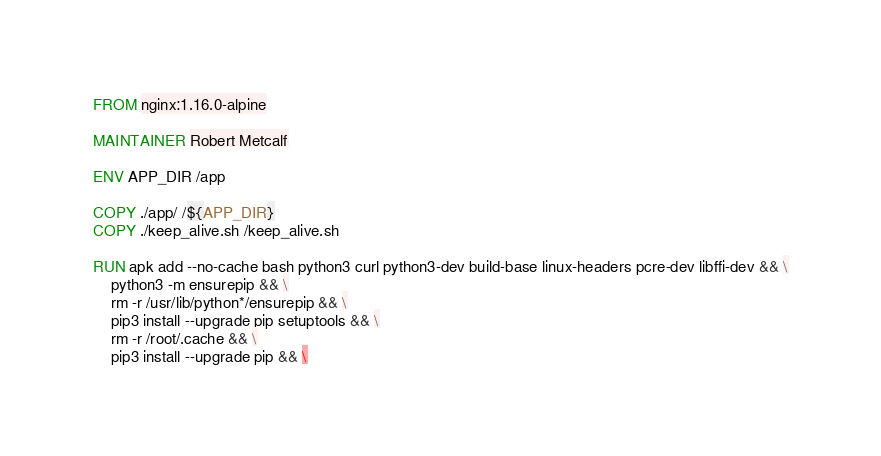Convert code to text. <code><loc_0><loc_0><loc_500><loc_500><_Dockerfile_>FROM nginx:1.16.0-alpine

MAINTAINER Robert Metcalf

ENV APP_DIR /app

COPY ./app/ /${APP_DIR}
COPY ./keep_alive.sh /keep_alive.sh

RUN apk add --no-cache bash python3 curl python3-dev build-base linux-headers pcre-dev libffi-dev && \
    python3 -m ensurepip && \
    rm -r /usr/lib/python*/ensurepip && \
    pip3 install --upgrade pip setuptools && \
    rm -r /root/.cache && \
    pip3 install --upgrade pip && \</code> 